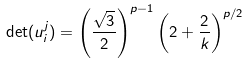Convert formula to latex. <formula><loc_0><loc_0><loc_500><loc_500>\det ( u _ { i } ^ { j } ) = \left ( \frac { \sqrt { 3 } } { 2 } \right ) ^ { p - 1 } \left ( 2 + \frac { 2 } { k } \right ) ^ { p / 2 }</formula> 